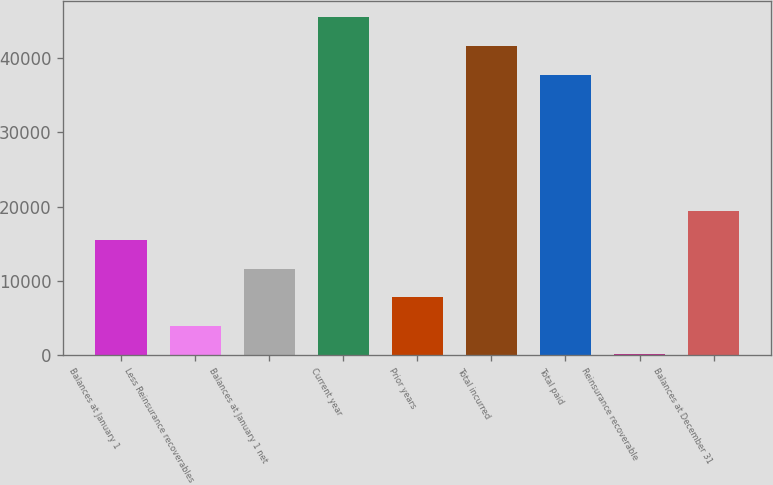<chart> <loc_0><loc_0><loc_500><loc_500><bar_chart><fcel>Balances at January 1<fcel>Less Reinsurance recoverables<fcel>Balances at January 1 net<fcel>Current year<fcel>Prior years<fcel>Total incurred<fcel>Total paid<fcel>Reinsurance recoverable<fcel>Balances at December 31<nl><fcel>15483.6<fcel>3923.4<fcel>11630.2<fcel>45461.8<fcel>7776.8<fcel>41608.4<fcel>37755<fcel>70<fcel>19337<nl></chart> 